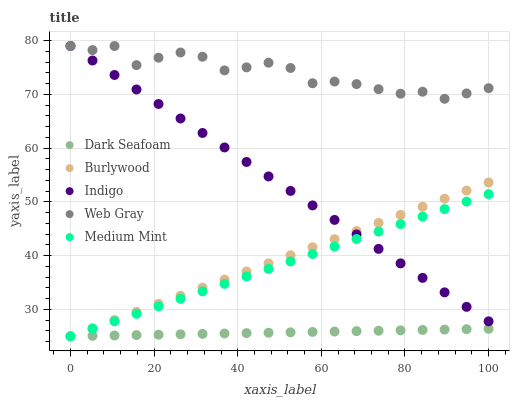Does Dark Seafoam have the minimum area under the curve?
Answer yes or no. Yes. Does Web Gray have the maximum area under the curve?
Answer yes or no. Yes. Does Medium Mint have the minimum area under the curve?
Answer yes or no. No. Does Medium Mint have the maximum area under the curve?
Answer yes or no. No. Is Dark Seafoam the smoothest?
Answer yes or no. Yes. Is Web Gray the roughest?
Answer yes or no. Yes. Is Medium Mint the smoothest?
Answer yes or no. No. Is Medium Mint the roughest?
Answer yes or no. No. Does Burlywood have the lowest value?
Answer yes or no. Yes. Does Web Gray have the lowest value?
Answer yes or no. No. Does Indigo have the highest value?
Answer yes or no. Yes. Does Medium Mint have the highest value?
Answer yes or no. No. Is Burlywood less than Web Gray?
Answer yes or no. Yes. Is Web Gray greater than Medium Mint?
Answer yes or no. Yes. Does Burlywood intersect Dark Seafoam?
Answer yes or no. Yes. Is Burlywood less than Dark Seafoam?
Answer yes or no. No. Is Burlywood greater than Dark Seafoam?
Answer yes or no. No. Does Burlywood intersect Web Gray?
Answer yes or no. No. 